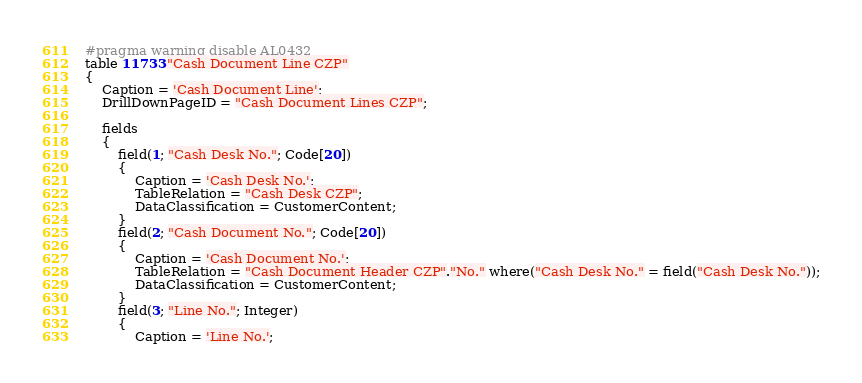Convert code to text. <code><loc_0><loc_0><loc_500><loc_500><_Perl_>#pragma warning disable AL0432
table 11733 "Cash Document Line CZP"
{
    Caption = 'Cash Document Line';
    DrillDownPageID = "Cash Document Lines CZP";

    fields
    {
        field(1; "Cash Desk No."; Code[20])
        {
            Caption = 'Cash Desk No.';
            TableRelation = "Cash Desk CZP";
            DataClassification = CustomerContent;
        }
        field(2; "Cash Document No."; Code[20])
        {
            Caption = 'Cash Document No.';
            TableRelation = "Cash Document Header CZP"."No." where("Cash Desk No." = field("Cash Desk No."));
            DataClassification = CustomerContent;
        }
        field(3; "Line No."; Integer)
        {
            Caption = 'Line No.';</code> 